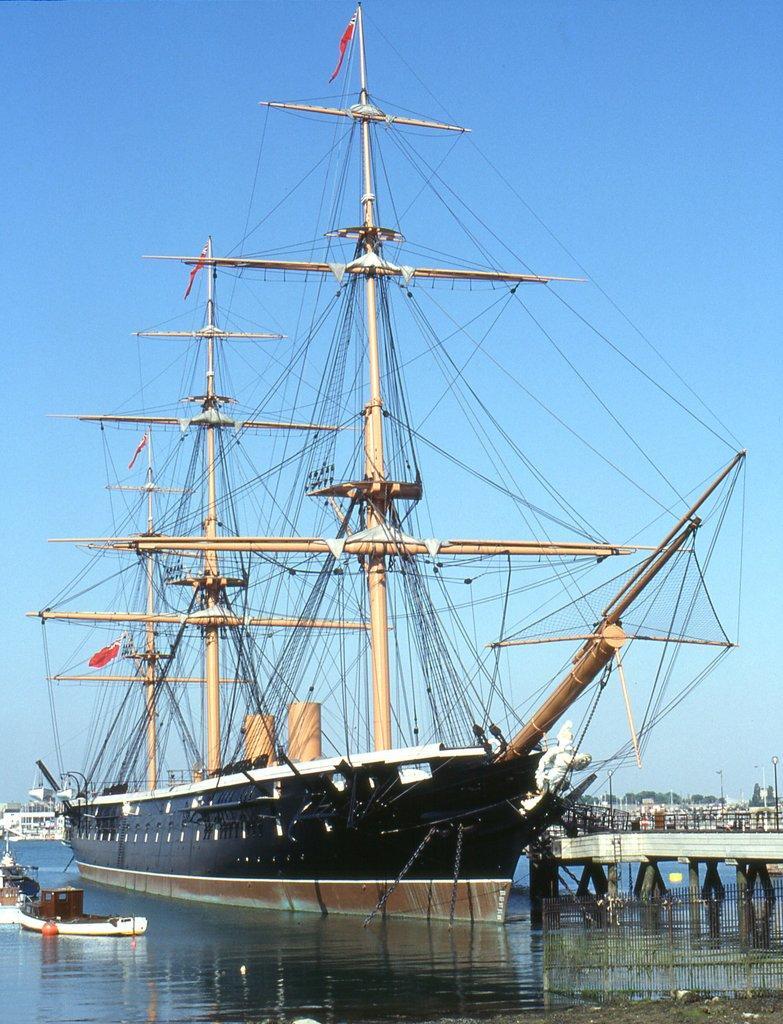Could you give a brief overview of what you see in this image? In this picture I can see a ship and boats on the water, there is a bridge, and in the background there is sky. 